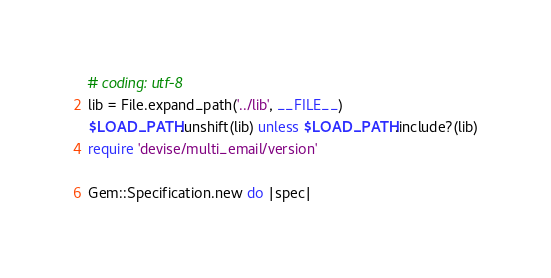<code> <loc_0><loc_0><loc_500><loc_500><_Ruby_># coding: utf-8
lib = File.expand_path('../lib', __FILE__)
$LOAD_PATH.unshift(lib) unless $LOAD_PATH.include?(lib)
require 'devise/multi_email/version'

Gem::Specification.new do |spec|</code> 